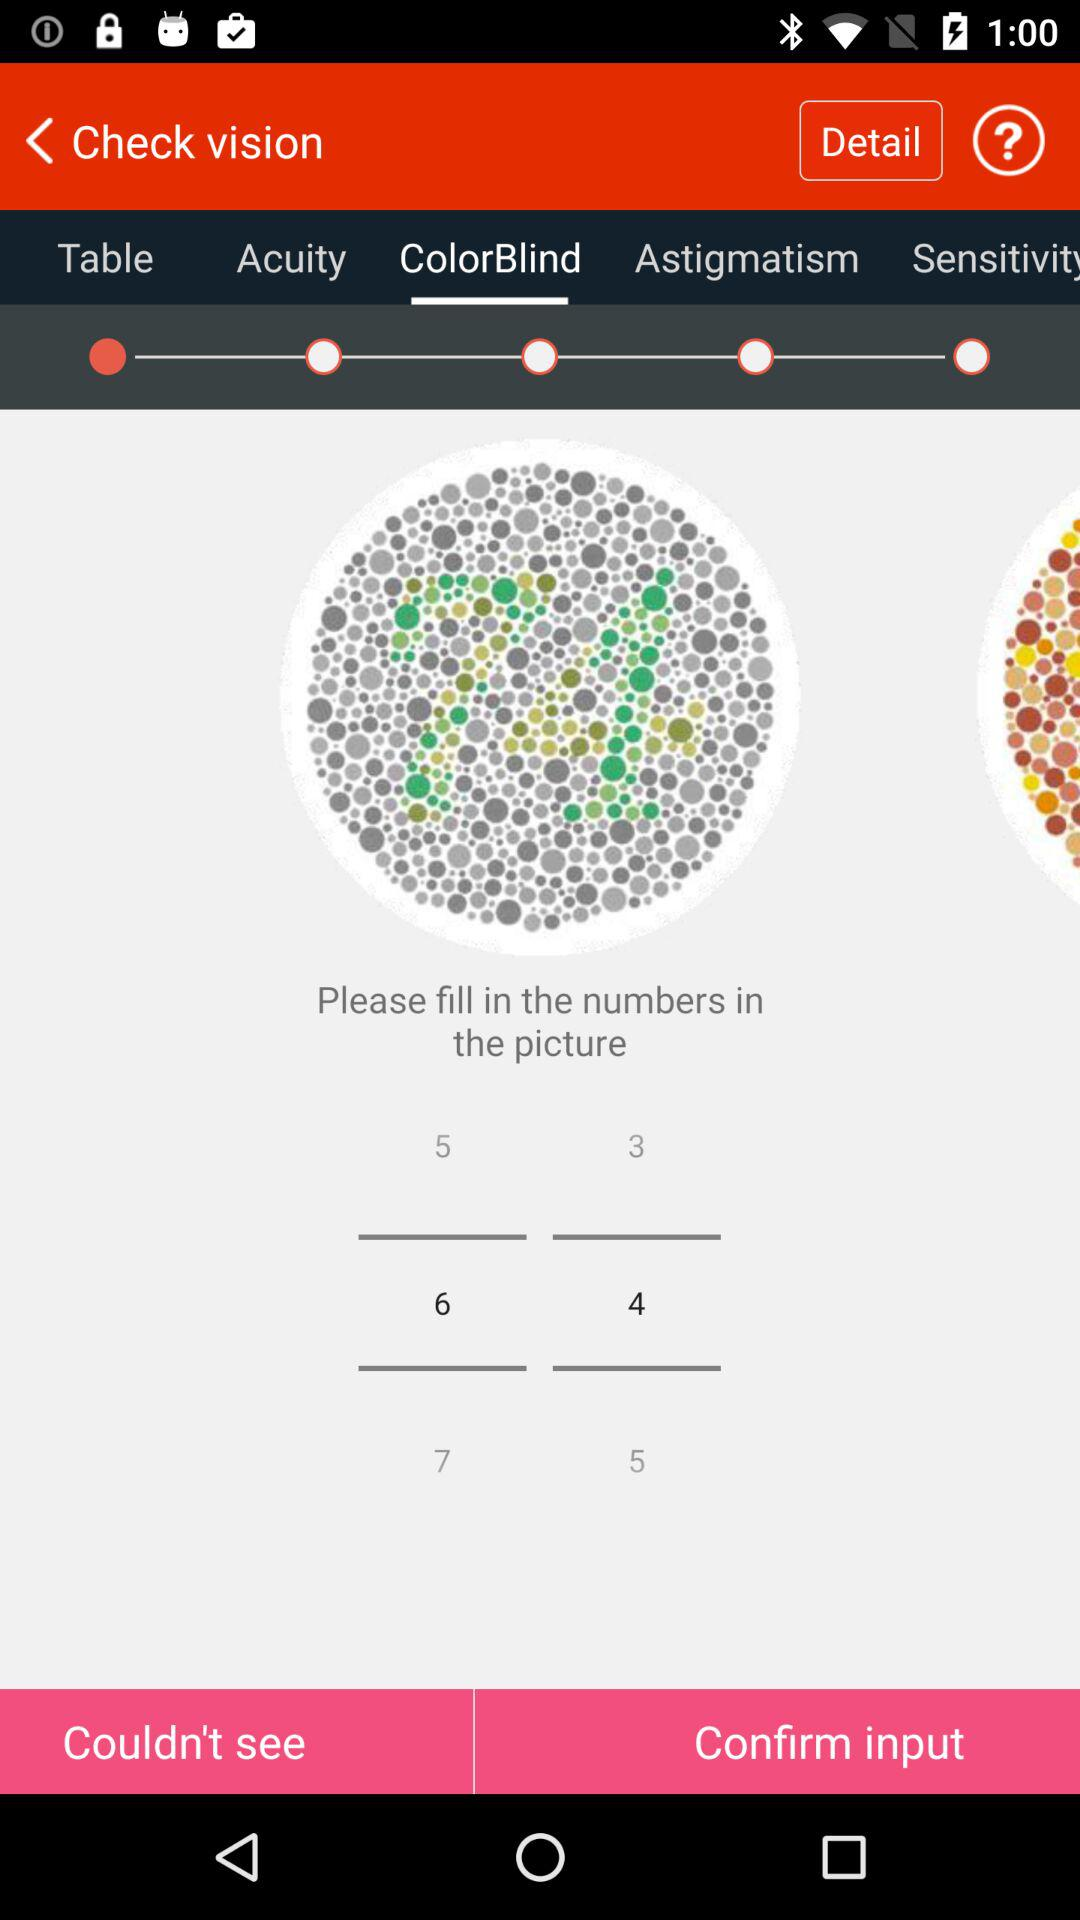How long does the user have to answer the question?
When the provided information is insufficient, respond with <no answer>. <no answer> 